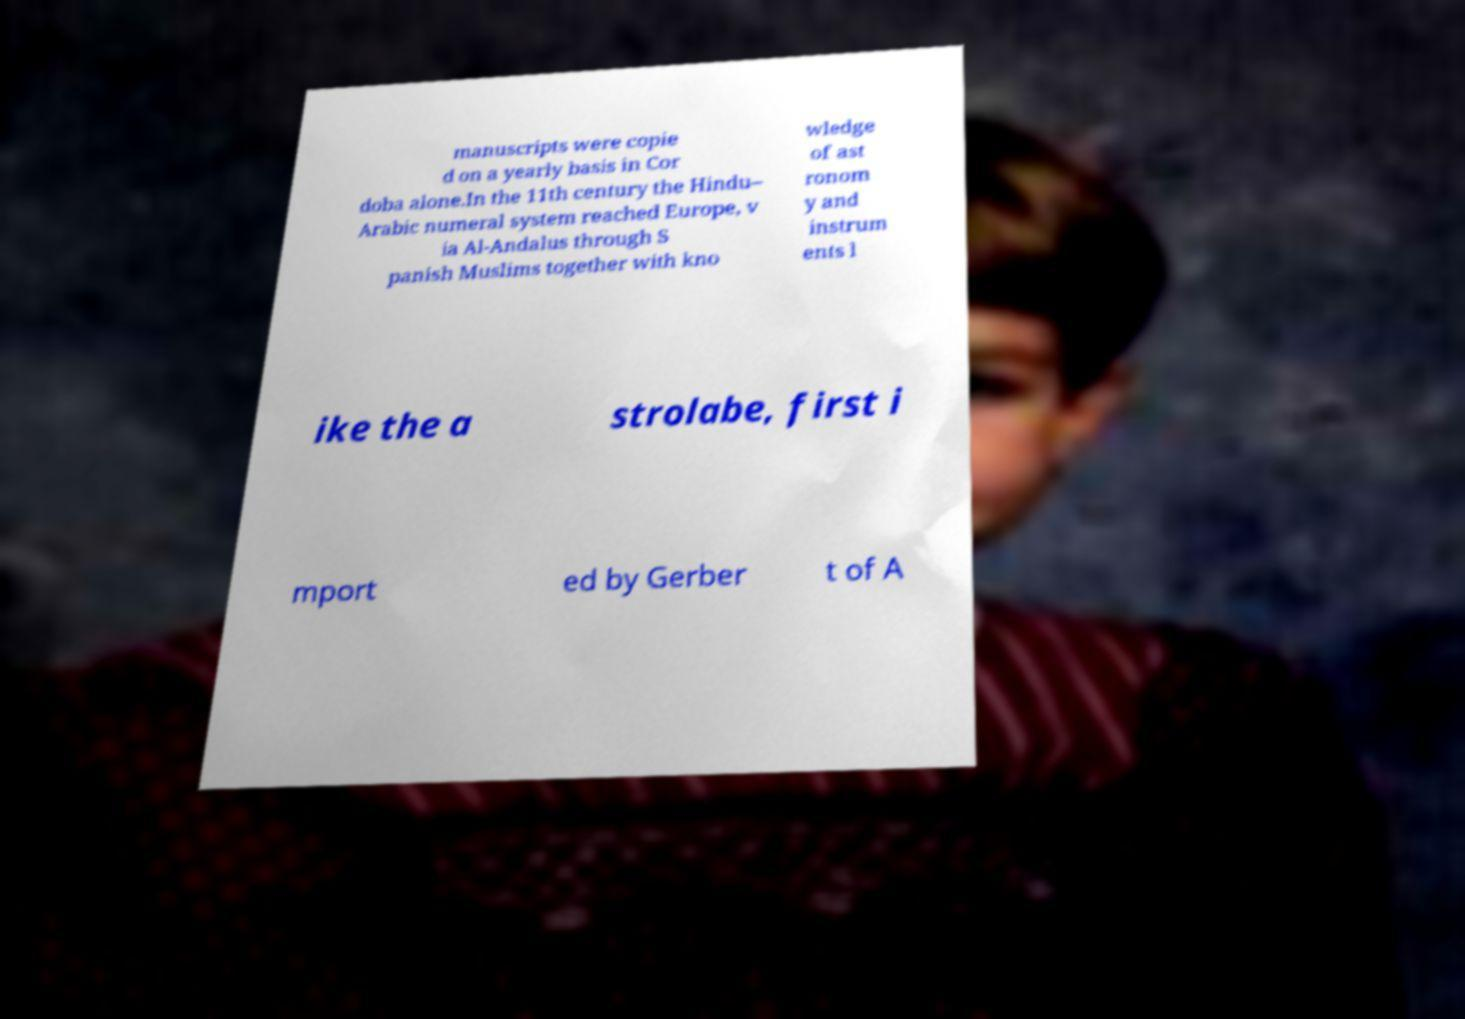For documentation purposes, I need the text within this image transcribed. Could you provide that? manuscripts were copie d on a yearly basis in Cor doba alone.In the 11th century the Hindu– Arabic numeral system reached Europe, v ia Al-Andalus through S panish Muslims together with kno wledge of ast ronom y and instrum ents l ike the a strolabe, first i mport ed by Gerber t of A 